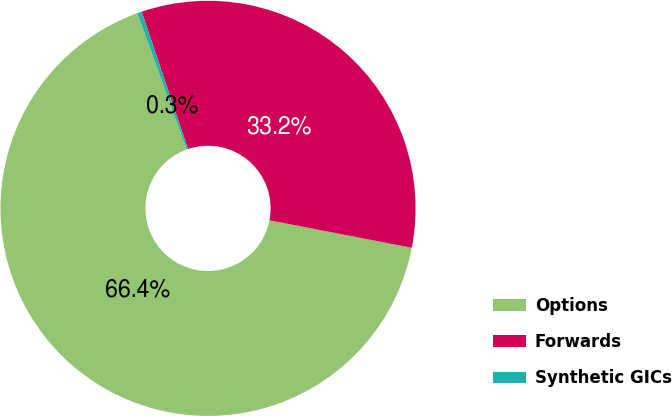<chart> <loc_0><loc_0><loc_500><loc_500><pie_chart><fcel>Options<fcel>Forwards<fcel>Synthetic GICs<nl><fcel>66.43%<fcel>33.22%<fcel>0.35%<nl></chart> 